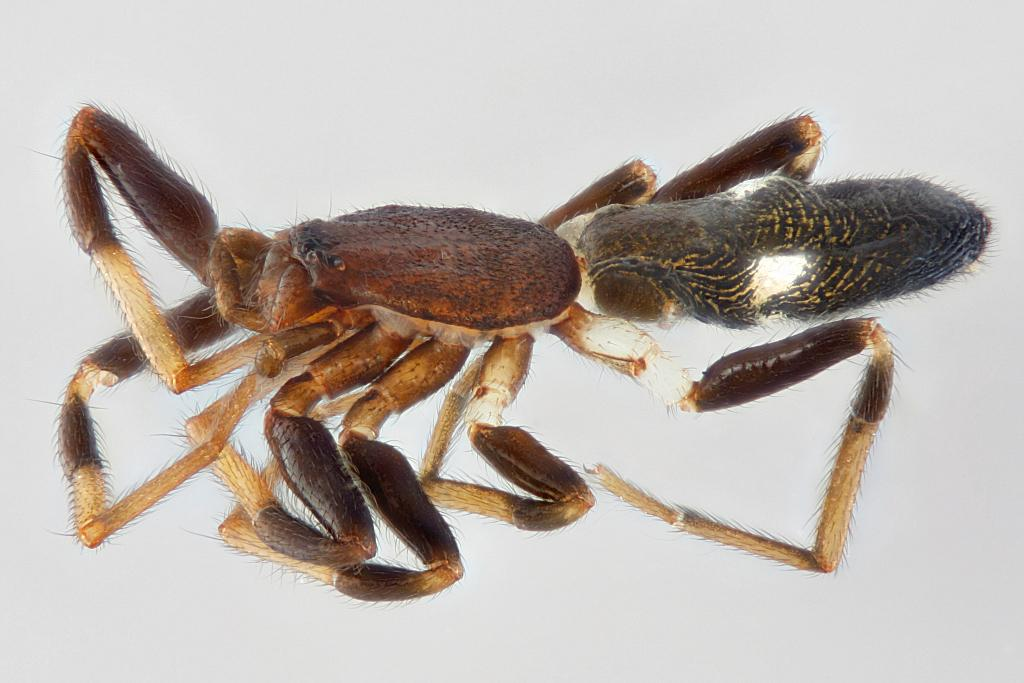What type of creature is present in the image? There is an insect in the image. Can you describe the colors of the insect? The insect has brown, black, and cream colors. What is the color of the background in the image? The background of the image is white. What type of rod can be seen in the image? There is no rod present in the image; it features an insect with specific colors against a white background. 